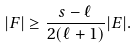<formula> <loc_0><loc_0><loc_500><loc_500>| F | \geq \frac { s - \ell } { 2 ( \ell + 1 ) } | E | .</formula> 